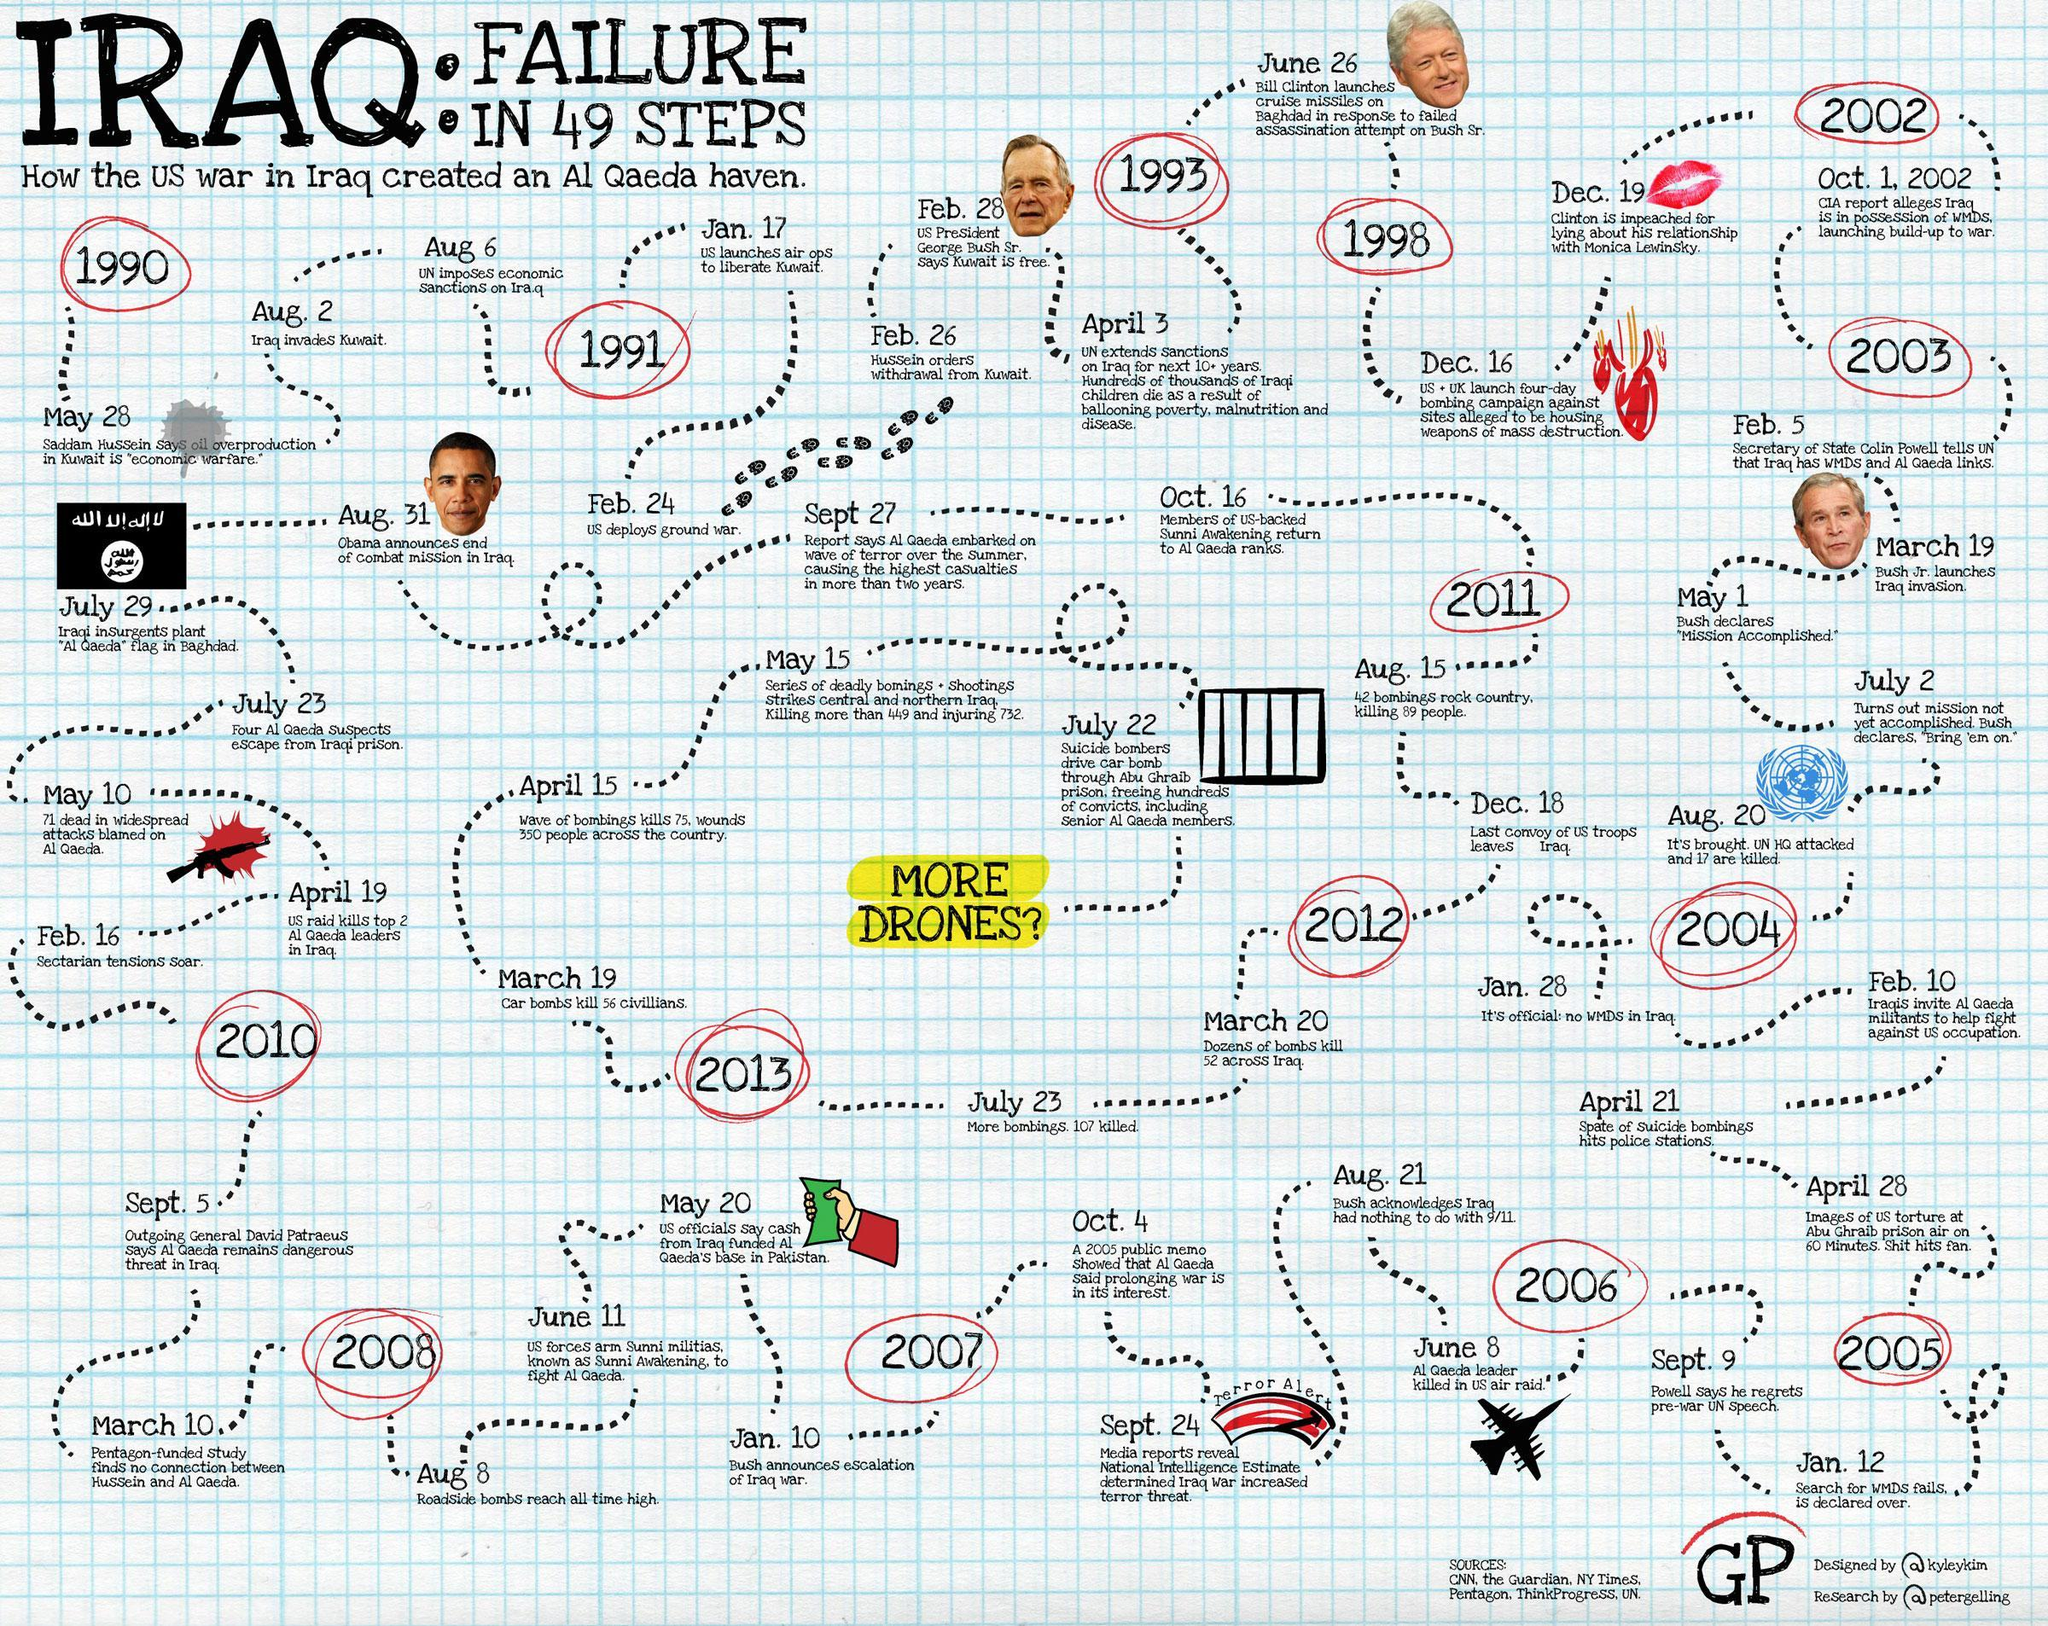What is the social media handle of the researcher of infographic?
Answer the question with a short phrase. @petergelling How many planes are shown in the infographic? 1 What is the social media handle of the designer of infographic? @kyleykim How many US presidents are shown in the infographic? 4 How many sources are listed? 6 